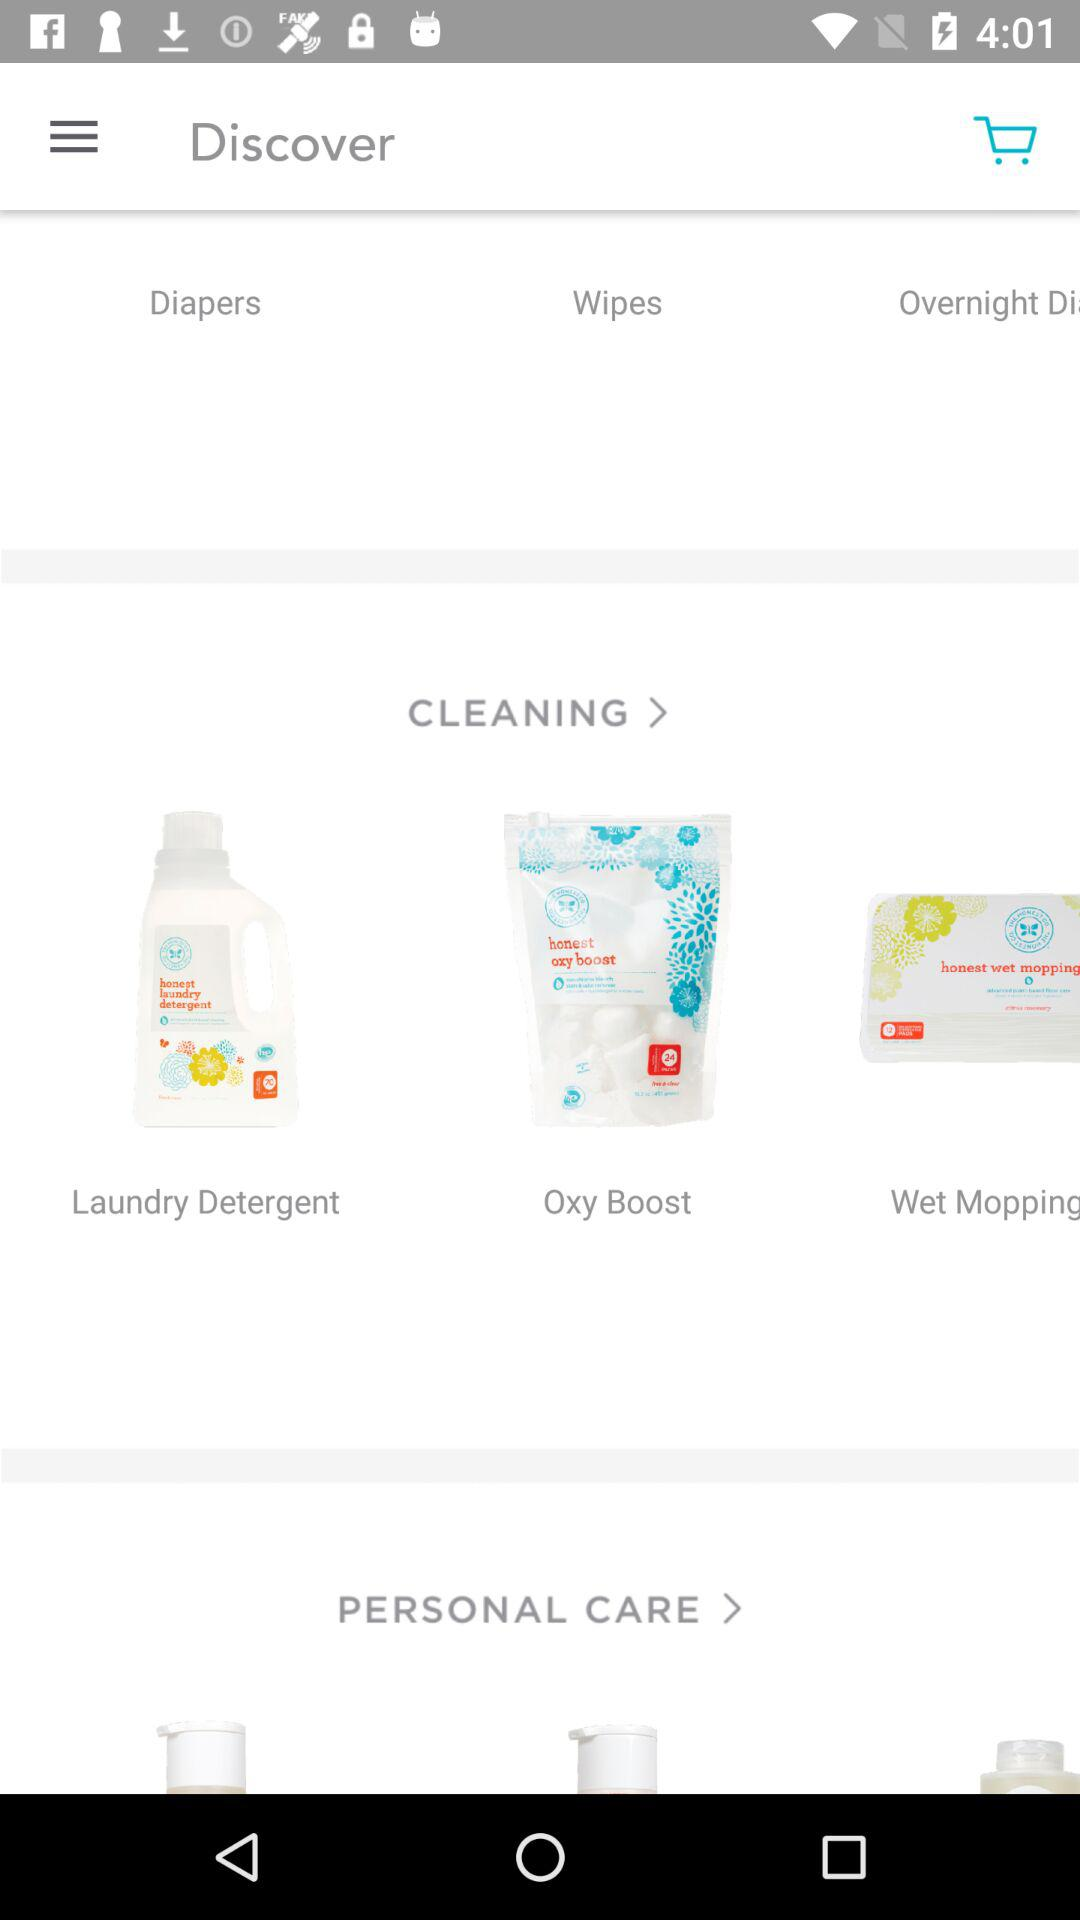Is there any item in the cart?
When the provided information is insufficient, respond with <no answer>. <no answer> 